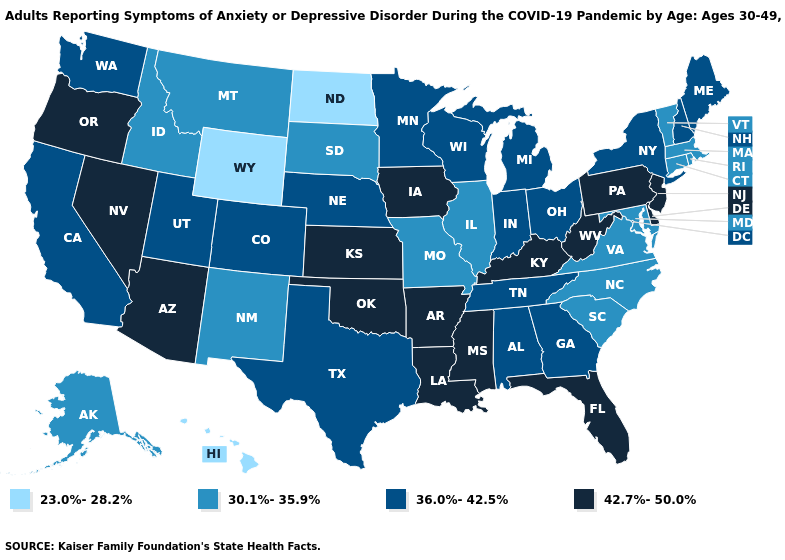Among the states that border Oregon , which have the lowest value?
Concise answer only. Idaho. Among the states that border New Mexico , does Utah have the highest value?
Concise answer only. No. Name the states that have a value in the range 36.0%-42.5%?
Quick response, please. Alabama, California, Colorado, Georgia, Indiana, Maine, Michigan, Minnesota, Nebraska, New Hampshire, New York, Ohio, Tennessee, Texas, Utah, Washington, Wisconsin. Does Iowa have the same value as Georgia?
Short answer required. No. Does Kansas have the lowest value in the MidWest?
Short answer required. No. What is the value of South Carolina?
Keep it brief. 30.1%-35.9%. Name the states that have a value in the range 30.1%-35.9%?
Keep it brief. Alaska, Connecticut, Idaho, Illinois, Maryland, Massachusetts, Missouri, Montana, New Mexico, North Carolina, Rhode Island, South Carolina, South Dakota, Vermont, Virginia. What is the highest value in the West ?
Concise answer only. 42.7%-50.0%. Name the states that have a value in the range 30.1%-35.9%?
Keep it brief. Alaska, Connecticut, Idaho, Illinois, Maryland, Massachusetts, Missouri, Montana, New Mexico, North Carolina, Rhode Island, South Carolina, South Dakota, Vermont, Virginia. Does Alaska have the highest value in the USA?
Write a very short answer. No. What is the highest value in the USA?
Be succinct. 42.7%-50.0%. Name the states that have a value in the range 36.0%-42.5%?
Keep it brief. Alabama, California, Colorado, Georgia, Indiana, Maine, Michigan, Minnesota, Nebraska, New Hampshire, New York, Ohio, Tennessee, Texas, Utah, Washington, Wisconsin. What is the lowest value in the South?
Short answer required. 30.1%-35.9%. What is the highest value in the USA?
Write a very short answer. 42.7%-50.0%. Among the states that border Montana , which have the highest value?
Quick response, please. Idaho, South Dakota. 